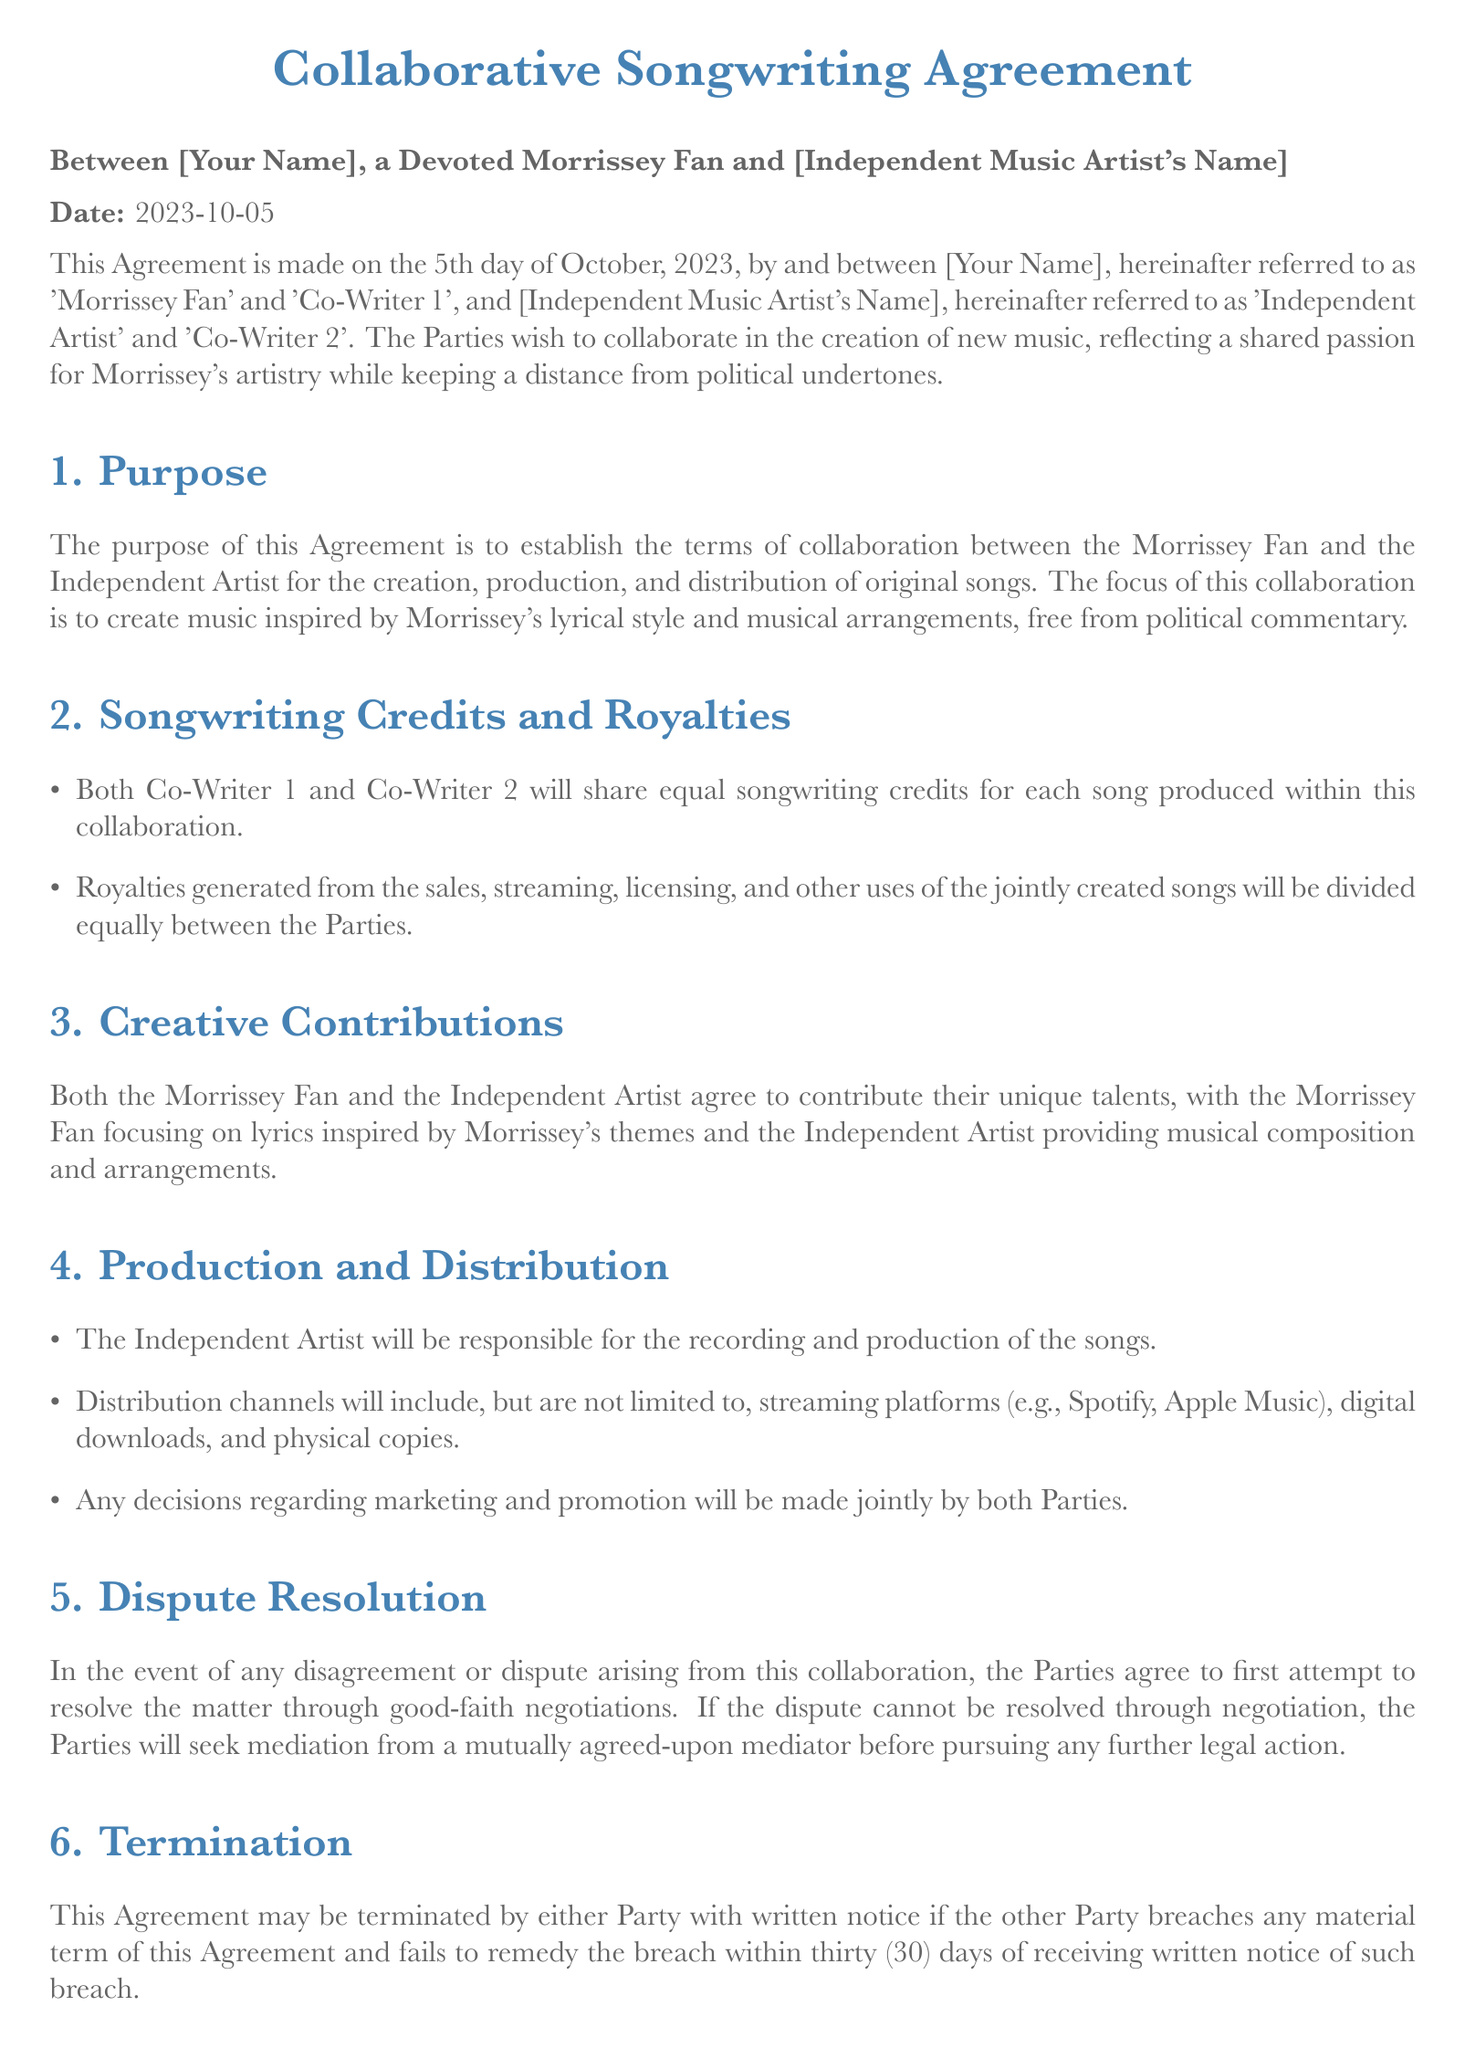What is the date of this Agreement? The date of the Agreement is explicitly mentioned in the document as October 5, 2023.
Answer: October 5, 2023 Who is identified as Co-Writer 1? Co-Writer 1 is referred to as 'Morrissey Fan' in the document, which represents the individual who identifies as a devoted fan of Morrissey's music.
Answer: Morrissey Fan What is the primary focus of the collaboration? The primary focus of the collaboration is stated as creating music inspired by Morrissey's lyrical style and musical arrangements, while avoiding political commentary.
Answer: Music inspired by Morrissey's lyrical style How will royalties from the songs be divided? The document specifies that royalties generated from sales and other uses of the songs will be divided equally between both Parties involved.
Answer: Equally What happens if there is a disagreement or dispute? In the event of a disagreement, the Parties agree to attempt to resolve it through good-faith negotiations before seeking mediation.
Answer: Good-faith negotiations What is required for either Party to terminate this Agreement? The Agreement can be terminated if one Party breaches any material term and fails to remedy the breach within thirty days of receiving notification.
Answer: Written notice What responsibilities does the Independent Artist have regarding the songs? The Independent Artist is responsible for the recording and production of the songs as per the terms laid out in the document.
Answer: Recording and production How are marketing and promotion decisions to be made? Marketing and promotion decisions will be made jointly by both the Morrissey Fan and the Independent Artist, indicating collaboration in these areas.
Answer: Jointly by both Parties 